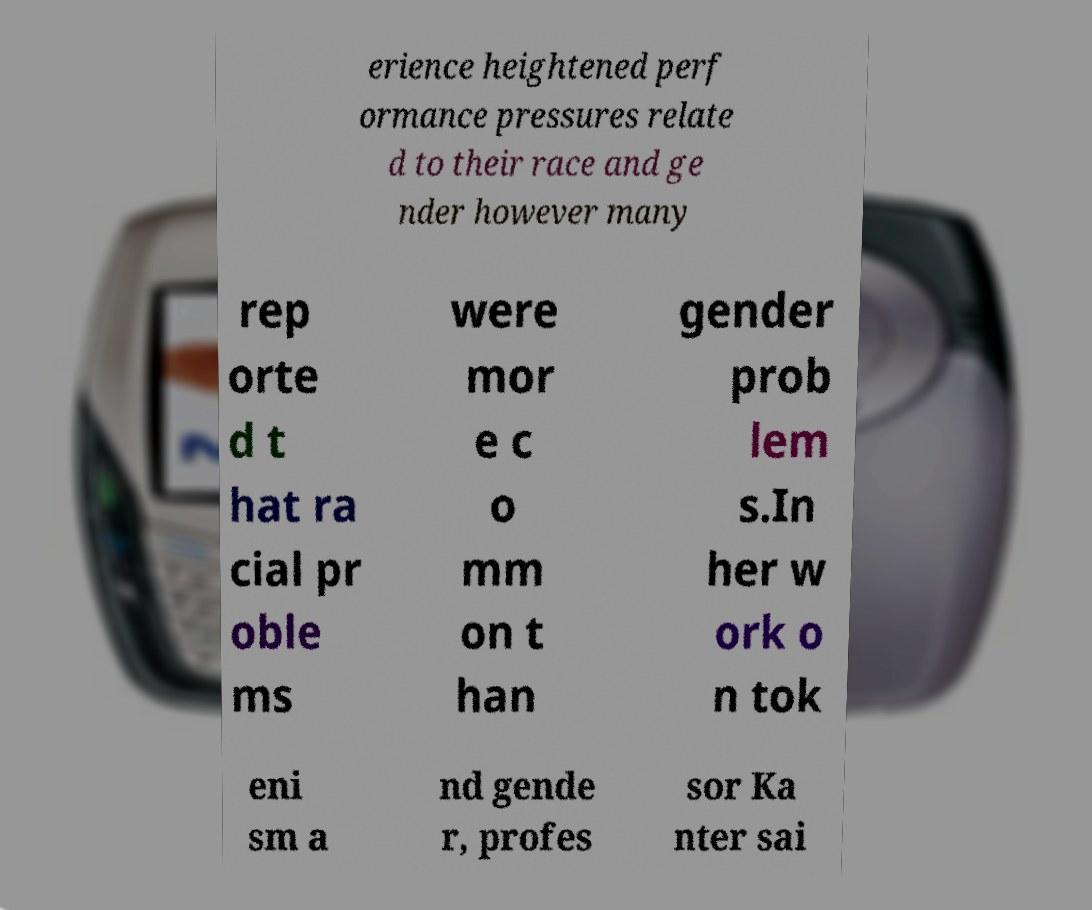Can you read and provide the text displayed in the image?This photo seems to have some interesting text. Can you extract and type it out for me? erience heightened perf ormance pressures relate d to their race and ge nder however many rep orte d t hat ra cial pr oble ms were mor e c o mm on t han gender prob lem s.In her w ork o n tok eni sm a nd gende r, profes sor Ka nter sai 